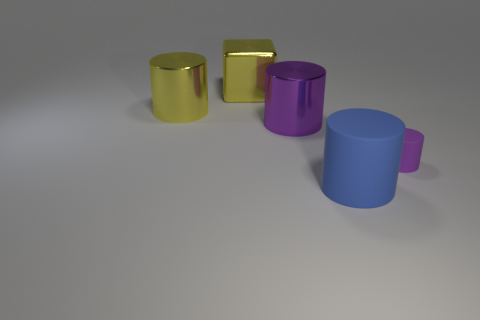How many other things are made of the same material as the blue thing?
Your answer should be compact. 1. Do the large purple cylinder and the yellow block left of the blue object have the same material?
Ensure brevity in your answer.  Yes. What is the material of the blue cylinder?
Provide a succinct answer. Rubber. What is the material of the big yellow thing that is to the right of the metallic cylinder behind the shiny cylinder to the right of the large yellow block?
Keep it short and to the point. Metal. There is a big shiny block; is its color the same as the big cylinder that is on the left side of the shiny cube?
Your response must be concise. Yes. Are there any other things that are the same shape as the large matte thing?
Your answer should be compact. Yes. There is a large metallic cylinder that is on the right side of the yellow thing that is behind the yellow cylinder; what is its color?
Your response must be concise. Purple. How many purple cylinders are there?
Provide a short and direct response. 2. What number of metallic things are cubes or tiny brown cylinders?
Make the answer very short. 1. How many shiny cubes are the same color as the large matte cylinder?
Offer a terse response. 0. 